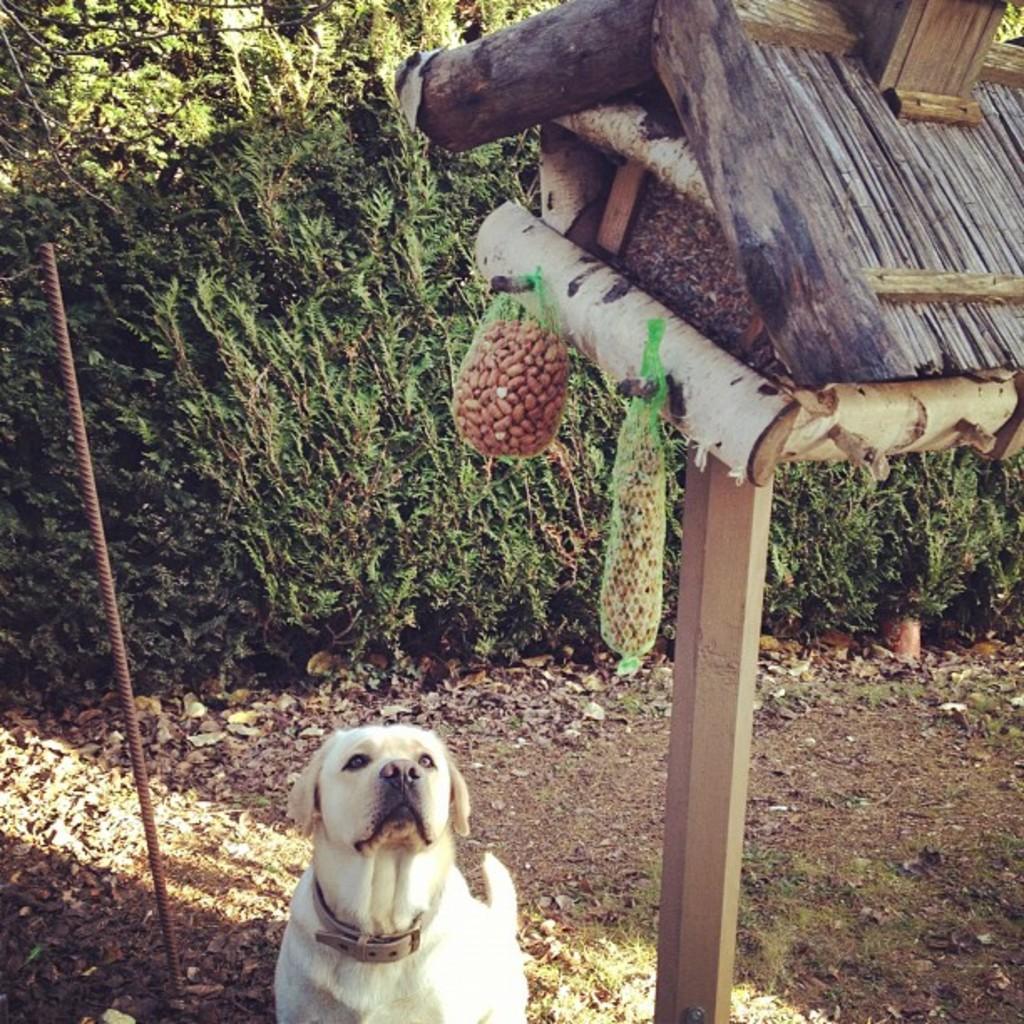Could you give a brief overview of what you see in this image? In this picture we can see a white color dog, beside to the dog we can find a metal rod and also we can see few plants. 